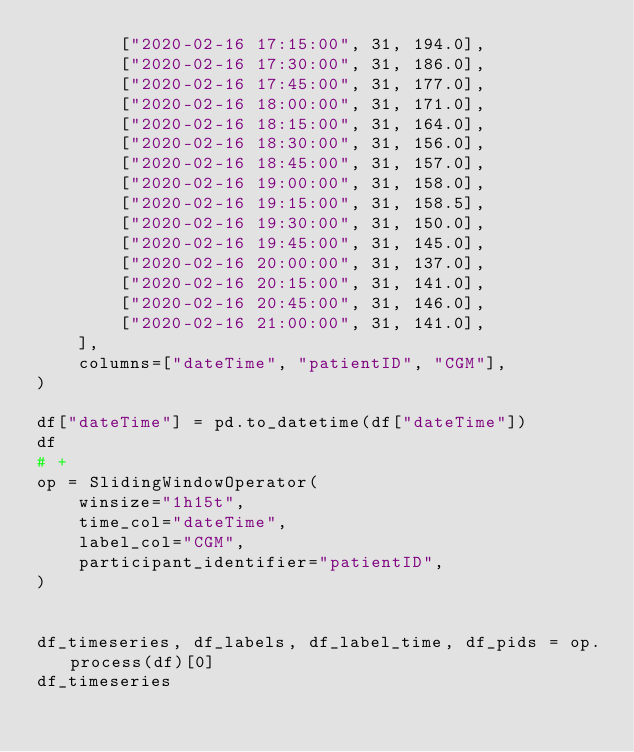<code> <loc_0><loc_0><loc_500><loc_500><_Python_>        ["2020-02-16 17:15:00", 31, 194.0],
        ["2020-02-16 17:30:00", 31, 186.0],
        ["2020-02-16 17:45:00", 31, 177.0],
        ["2020-02-16 18:00:00", 31, 171.0],
        ["2020-02-16 18:15:00", 31, 164.0],
        ["2020-02-16 18:30:00", 31, 156.0],
        ["2020-02-16 18:45:00", 31, 157.0],
        ["2020-02-16 19:00:00", 31, 158.0],
        ["2020-02-16 19:15:00", 31, 158.5],
        ["2020-02-16 19:30:00", 31, 150.0],
        ["2020-02-16 19:45:00", 31, 145.0],
        ["2020-02-16 20:00:00", 31, 137.0],
        ["2020-02-16 20:15:00", 31, 141.0],
        ["2020-02-16 20:45:00", 31, 146.0],
        ["2020-02-16 21:00:00", 31, 141.0],
    ],
    columns=["dateTime", "patientID", "CGM"],
)

df["dateTime"] = pd.to_datetime(df["dateTime"])
df
# +
op = SlidingWindowOperator(
    winsize="1h15t",
    time_col="dateTime",
    label_col="CGM",
    participant_identifier="patientID",
)


df_timeseries, df_labels, df_label_time, df_pids = op.process(df)[0]
df_timeseries
</code> 